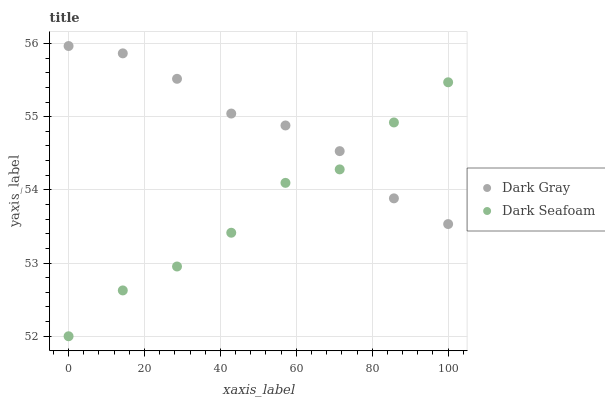Does Dark Seafoam have the minimum area under the curve?
Answer yes or no. Yes. Does Dark Gray have the maximum area under the curve?
Answer yes or no. Yes. Does Dark Seafoam have the maximum area under the curve?
Answer yes or no. No. Is Dark Gray the smoothest?
Answer yes or no. Yes. Is Dark Seafoam the roughest?
Answer yes or no. Yes. Is Dark Seafoam the smoothest?
Answer yes or no. No. Does Dark Seafoam have the lowest value?
Answer yes or no. Yes. Does Dark Gray have the highest value?
Answer yes or no. Yes. Does Dark Seafoam have the highest value?
Answer yes or no. No. Does Dark Gray intersect Dark Seafoam?
Answer yes or no. Yes. Is Dark Gray less than Dark Seafoam?
Answer yes or no. No. Is Dark Gray greater than Dark Seafoam?
Answer yes or no. No. 